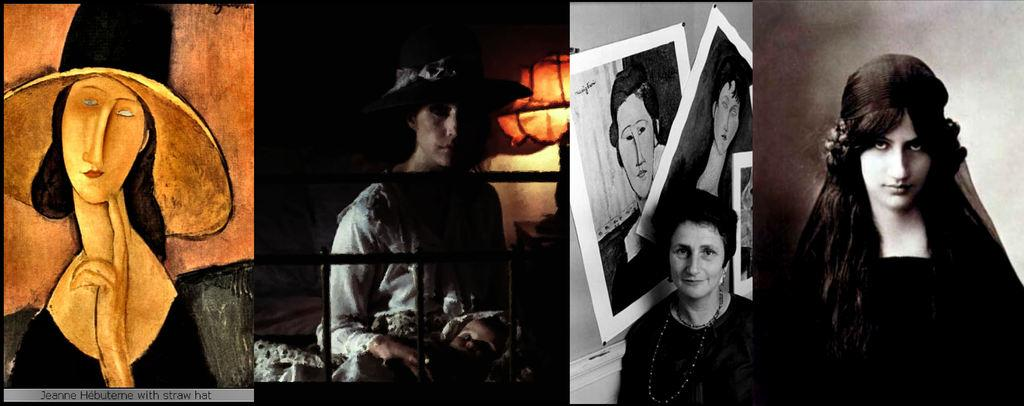How many people are in the image? There is a group of people in the image, but the exact number cannot be determined from the provided facts. What type of artwork is visible in the image? There are paintings, photo frames, and posters in the image. Can you describe the artwork in the image? The paintings, photo frames, and posters in the image cannot be described in detail based on the provided facts. Where is the river located in the image? There is no river present in the image. How many spiders are crawling on the paintings in the image? There is no mention of spiders in the image, and therefore no such activity can be observed. 